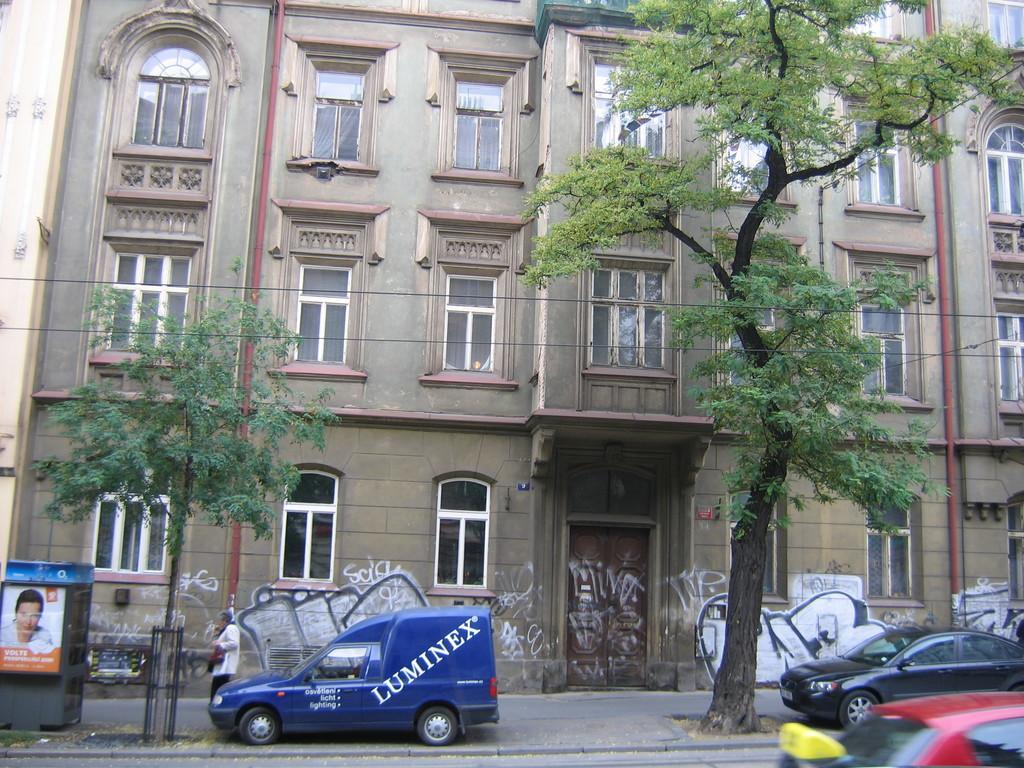What is the nae on the side of the blue van?
Your answer should be very brief. Luminex. What is the last word on the driver's side door?
Your answer should be compact. Lighting. 